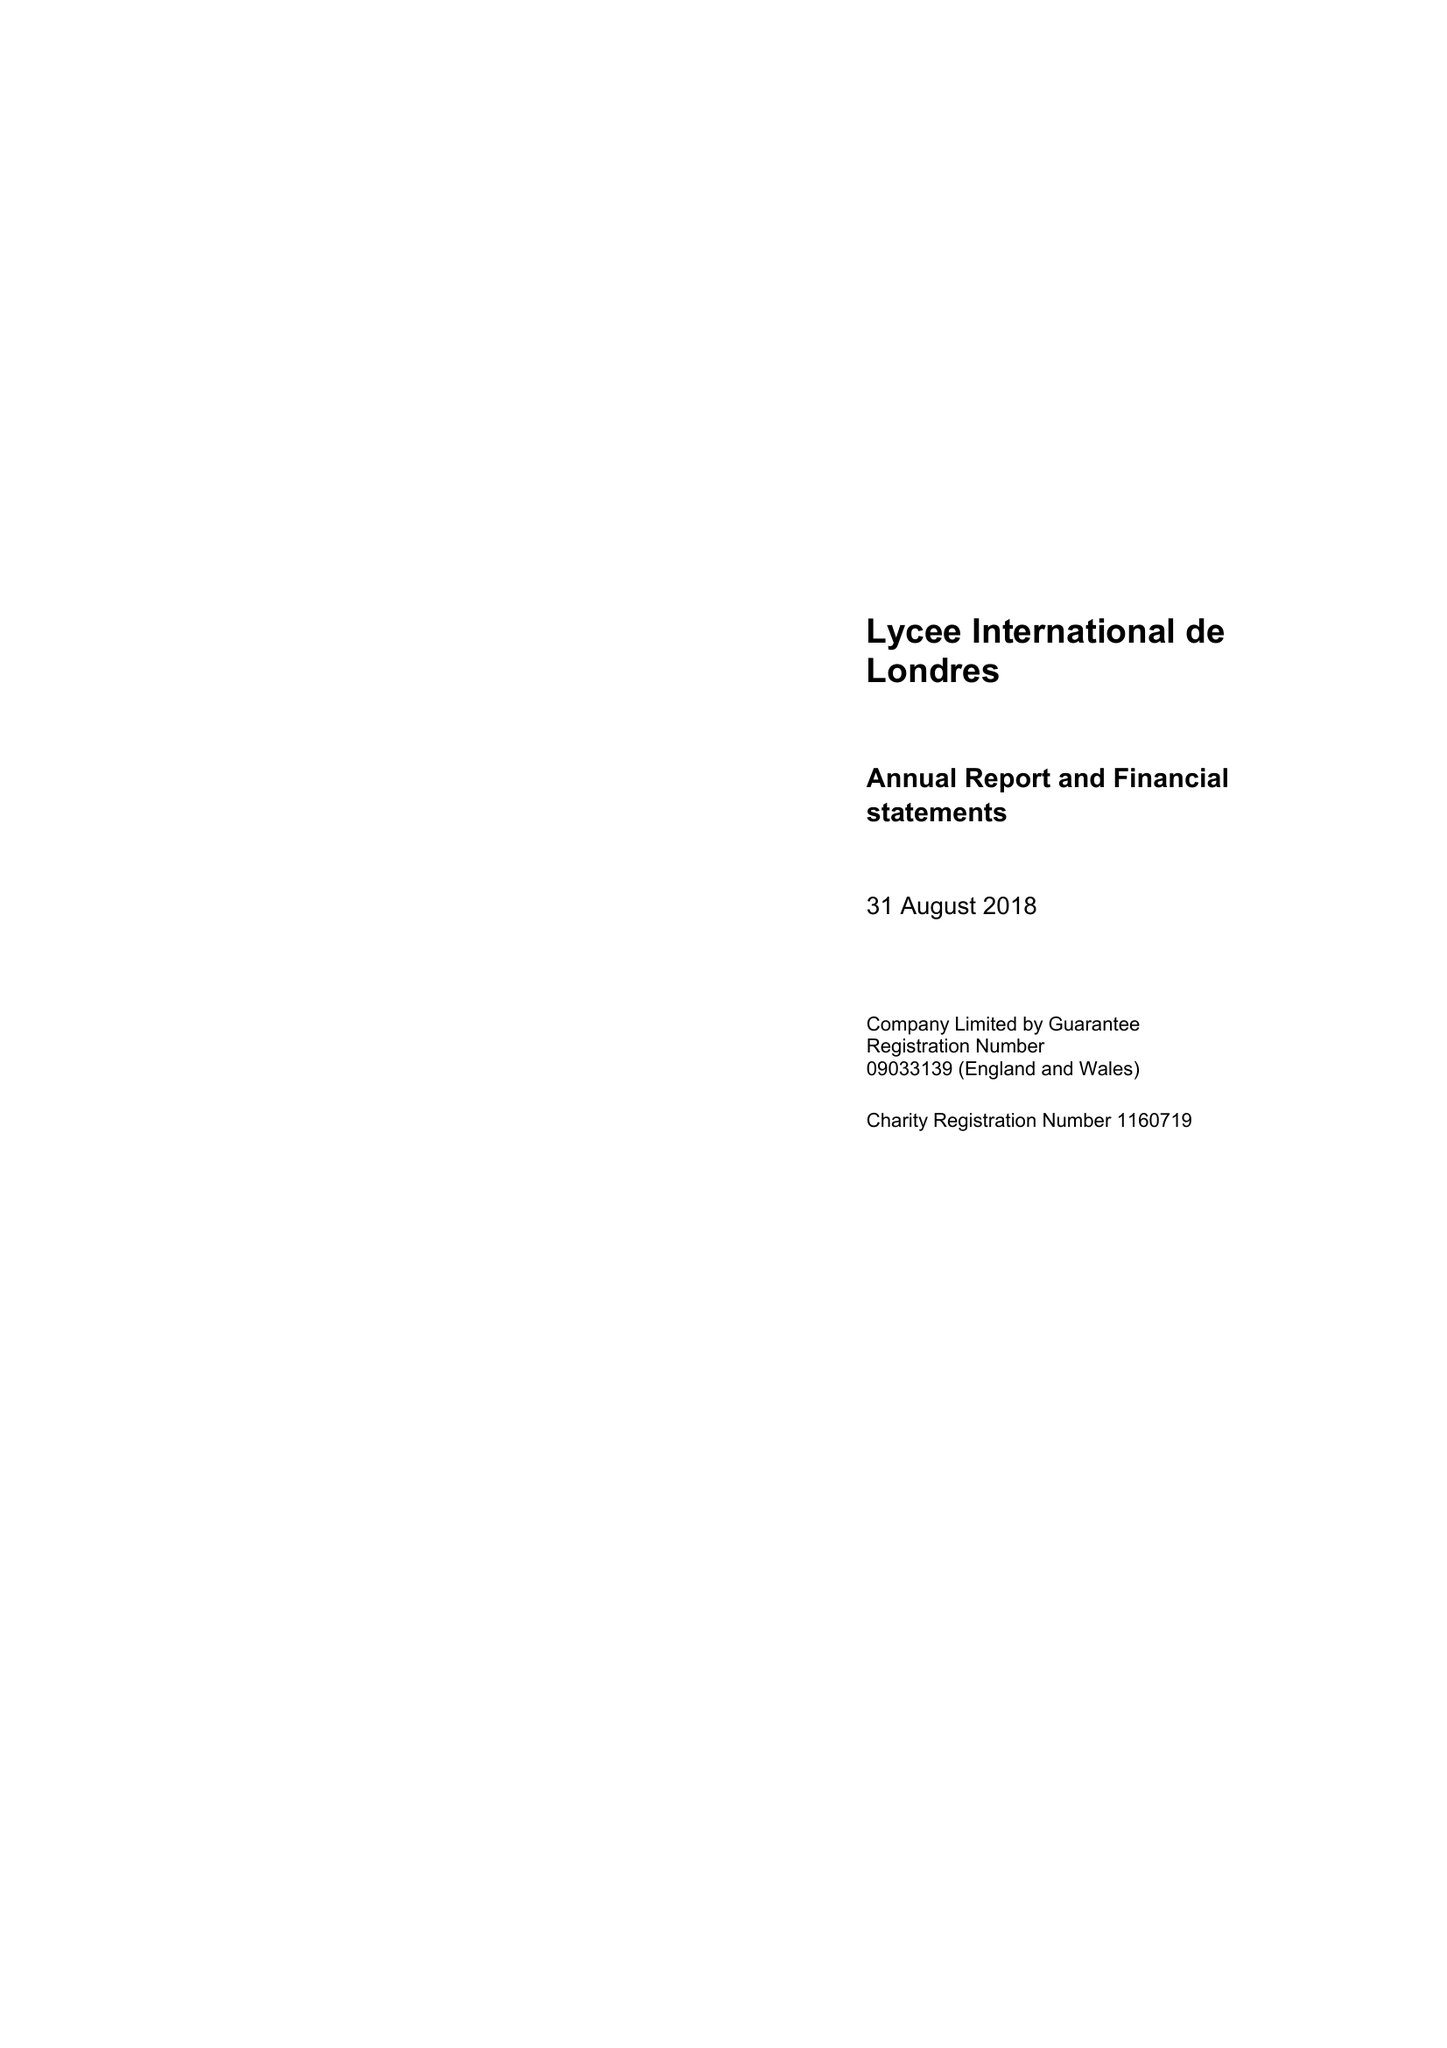What is the value for the charity_number?
Answer the question using a single word or phrase. 1160719 